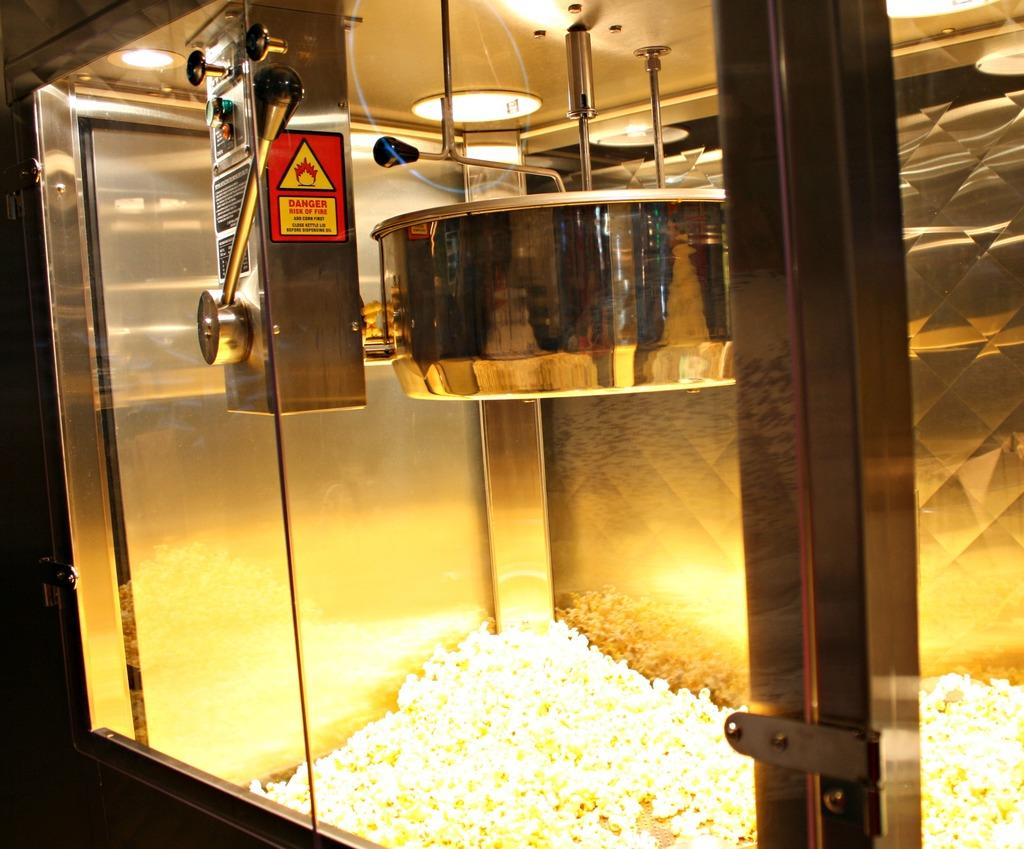What is the main object in the image? There is a container in the image. What is inside the container? The container has popcorn inside it. Can you describe the quantity of popcorn in the container? There is a significant amount of popcorn in the container. What type of jeans is being worn by the popcorn in the image? There are no jeans present in the image, as the image features a container with popcorn. What part of a farm animal is represented by the popcorn in the image? The popcorn in the image does not represent any part of a farm animal; it is simply popcorn in a container. 